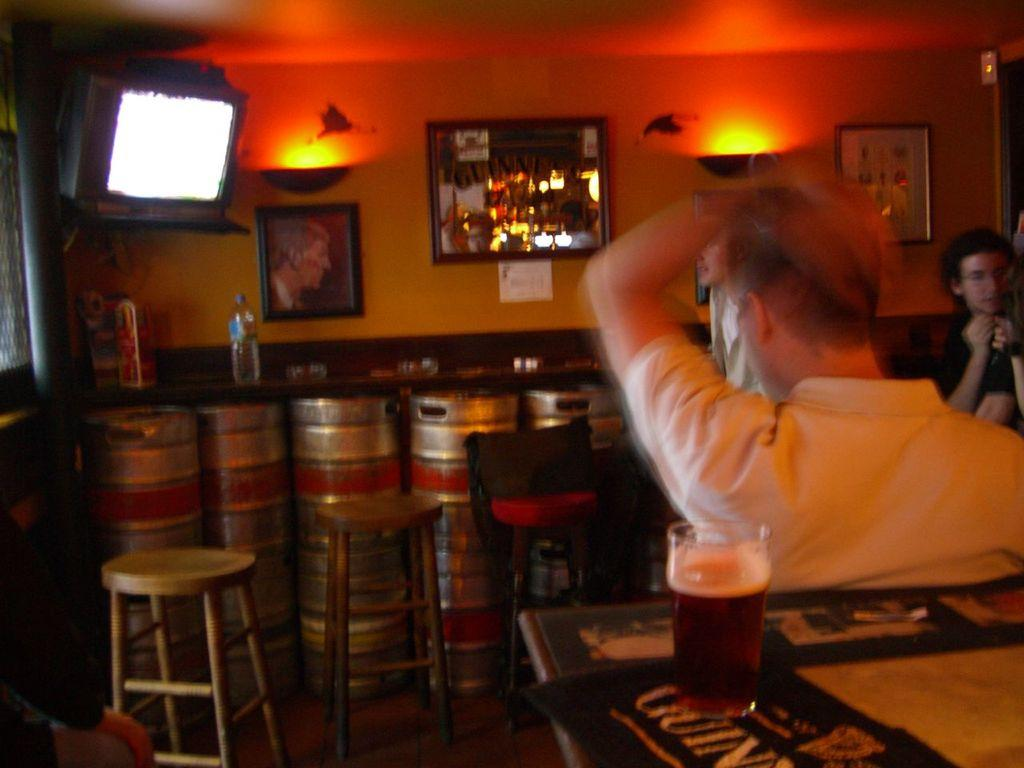Who is present in the image? There is a man in the image. What objects can be seen on a table in the image? There are bottles on a table in the image. How many apples are on the drum in the image? There are no apples or drums present in the image. 